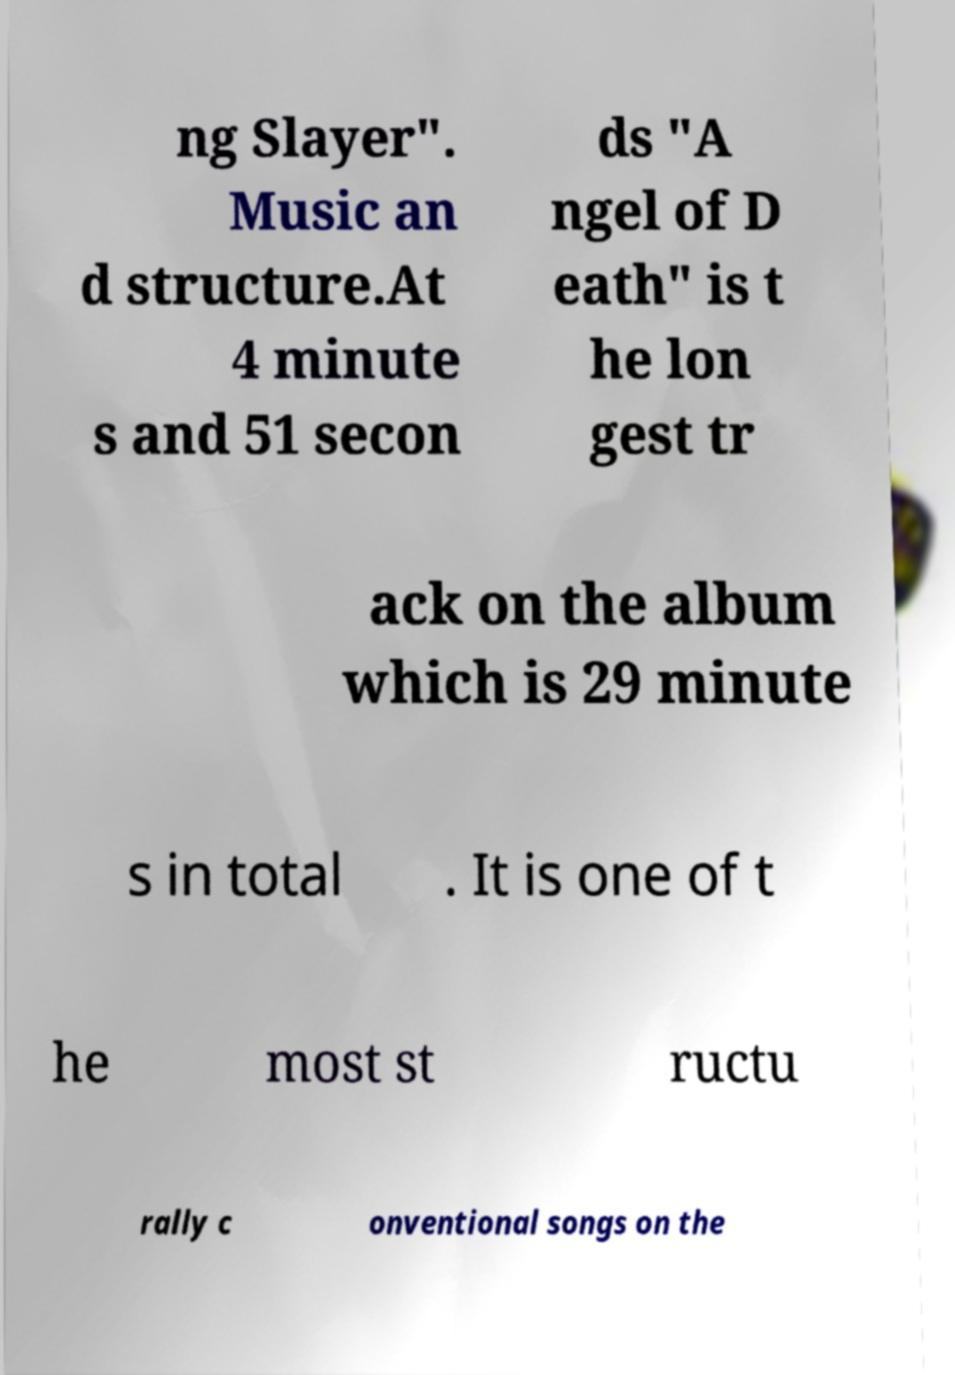Can you accurately transcribe the text from the provided image for me? ng Slayer". Music an d structure.At 4 minute s and 51 secon ds "A ngel of D eath" is t he lon gest tr ack on the album which is 29 minute s in total . It is one of t he most st ructu rally c onventional songs on the 